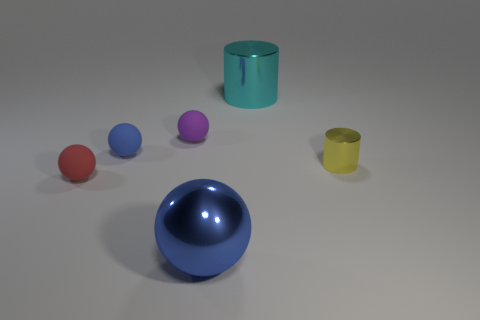Add 3 tiny gray rubber cylinders. How many objects exist? 9 Subtract all balls. How many objects are left? 2 Subtract all red matte balls. Subtract all tiny red matte objects. How many objects are left? 4 Add 3 small purple balls. How many small purple balls are left? 4 Add 4 tiny gray matte cylinders. How many tiny gray matte cylinders exist? 4 Subtract 0 gray blocks. How many objects are left? 6 